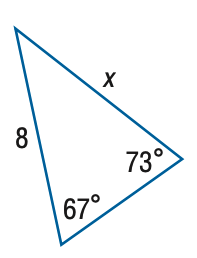Answer the mathemtical geometry problem and directly provide the correct option letter.
Question: Find x. Round side measure to the nearest tenth.
Choices: A: 5.4 B: 7.7 C: 8.3 D: 11.9 B 